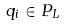<formula> <loc_0><loc_0><loc_500><loc_500>q _ { i } \in P _ { L }</formula> 